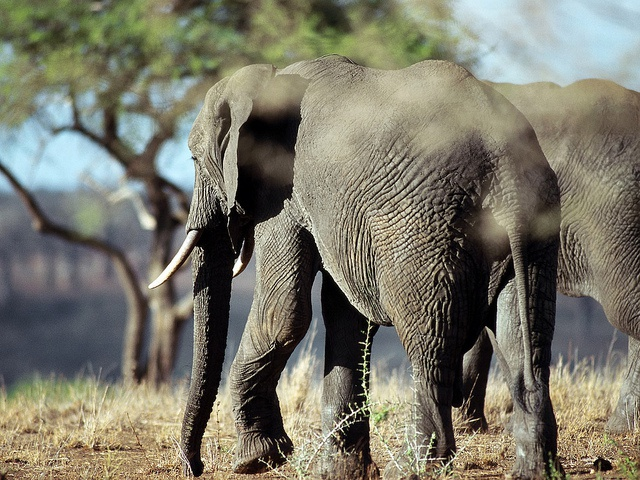Describe the objects in this image and their specific colors. I can see elephant in olive, black, darkgray, and gray tones and elephant in olive, gray, darkgray, and black tones in this image. 